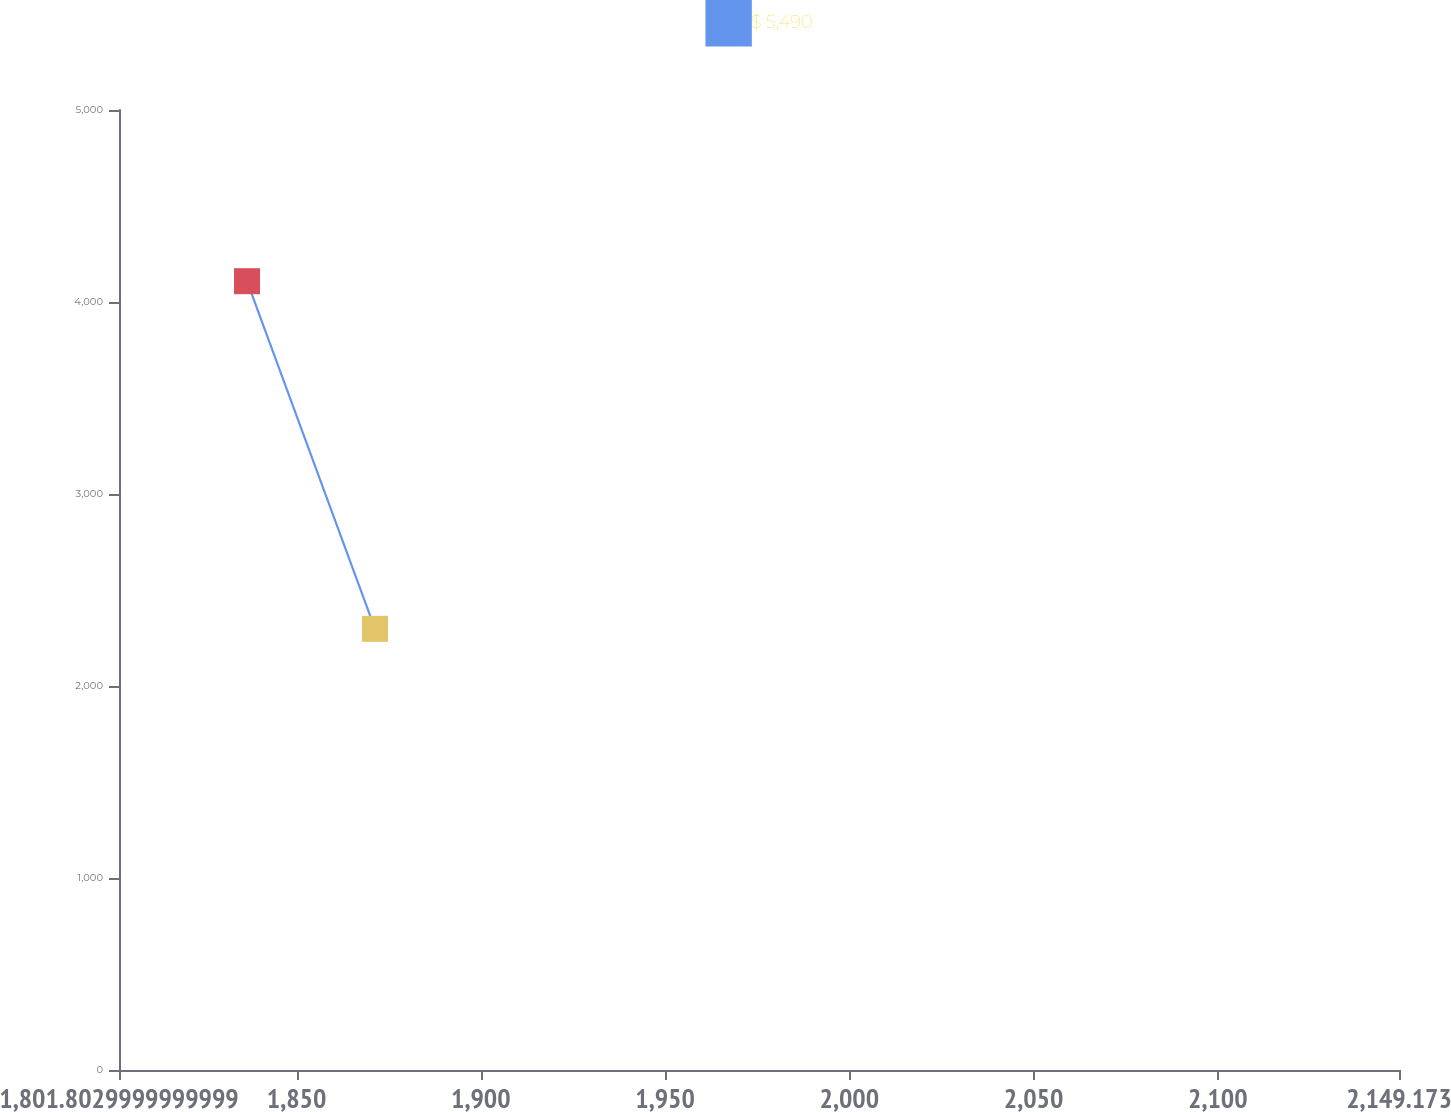Convert chart. <chart><loc_0><loc_0><loc_500><loc_500><line_chart><ecel><fcel>$ 5,490<nl><fcel>1836.54<fcel>4108.36<nl><fcel>1871.28<fcel>2297.76<nl><fcel>2183.91<fcel>665.92<nl></chart> 